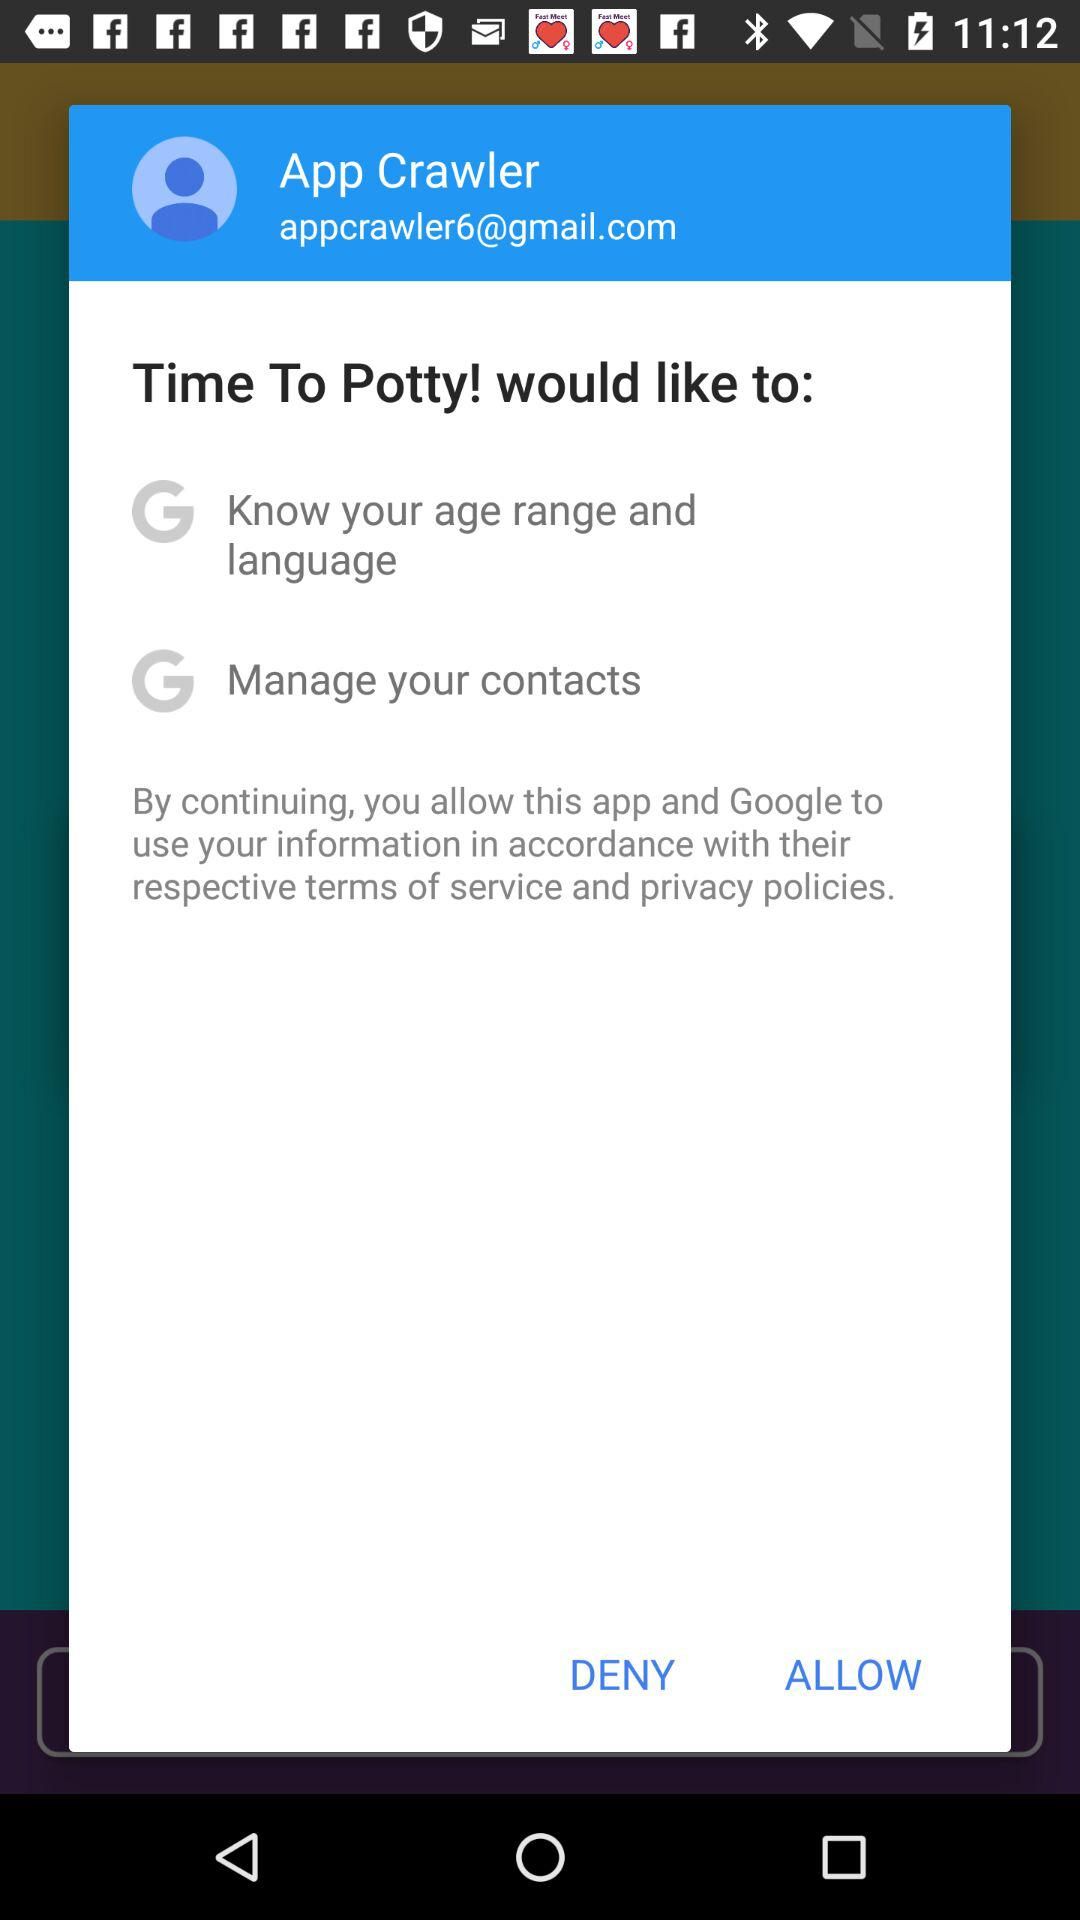What is the email address of the user? The email address is appcrawler6@gmail.com. 